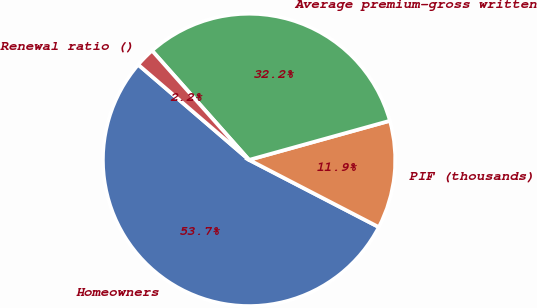Convert chart to OTSL. <chart><loc_0><loc_0><loc_500><loc_500><pie_chart><fcel>Homeowners<fcel>PIF (thousands)<fcel>Average premium-gross written<fcel>Renewal ratio ()<nl><fcel>53.68%<fcel>11.92%<fcel>32.24%<fcel>2.15%<nl></chart> 